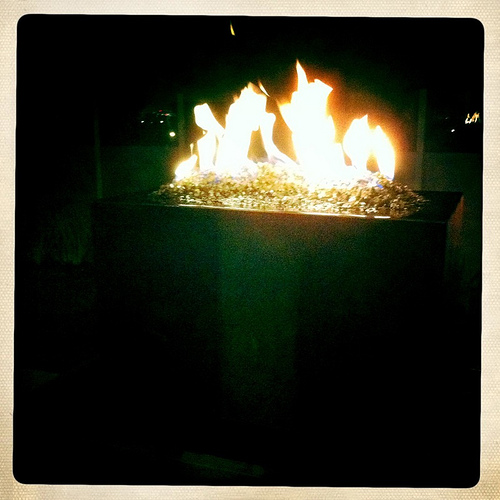<image>
Is there a fire above the table? Yes. The fire is positioned above the table in the vertical space, higher up in the scene. 